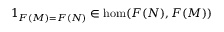Convert formula to latex. <formula><loc_0><loc_0><loc_500><loc_500>1 _ { F ( M ) = F ( N ) } \in \hom ( F ( N ) , F ( M ) )</formula> 